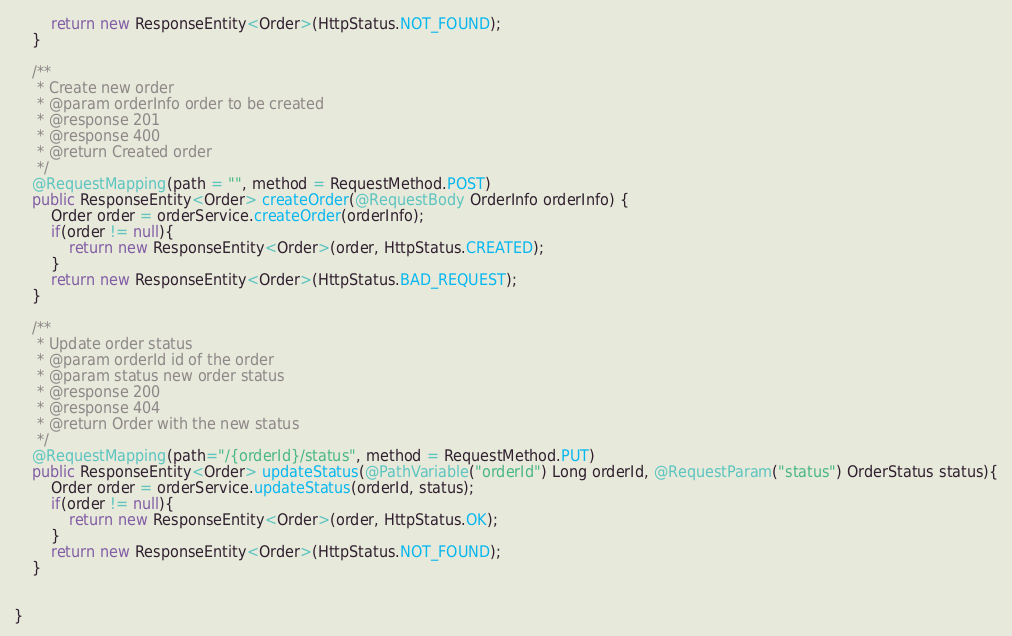<code> <loc_0><loc_0><loc_500><loc_500><_Java_>        return new ResponseEntity<Order>(HttpStatus.NOT_FOUND);
    }

    /**
     * Create new order
     * @param orderInfo order to be created
     * @response 201
     * @response 400
     * @return Created order
     */
    @RequestMapping(path = "", method = RequestMethod.POST)
    public ResponseEntity<Order> createOrder(@RequestBody OrderInfo orderInfo) {
        Order order = orderService.createOrder(orderInfo);
        if(order != null){
            return new ResponseEntity<Order>(order, HttpStatus.CREATED);
        }
        return new ResponseEntity<Order>(HttpStatus.BAD_REQUEST);
    }

    /**
     * Update order status
     * @param orderId id of the order
     * @param status new order status
     * @response 200
     * @response 404
     * @return Order with the new status
     */
    @RequestMapping(path="/{orderId}/status", method = RequestMethod.PUT)
    public ResponseEntity<Order> updateStatus(@PathVariable("orderId") Long orderId, @RequestParam("status") OrderStatus status){
        Order order = orderService.updateStatus(orderId, status);
        if(order != null){
            return new ResponseEntity<Order>(order, HttpStatus.OK);
        }
        return new ResponseEntity<Order>(HttpStatus.NOT_FOUND);
    }


}
</code> 